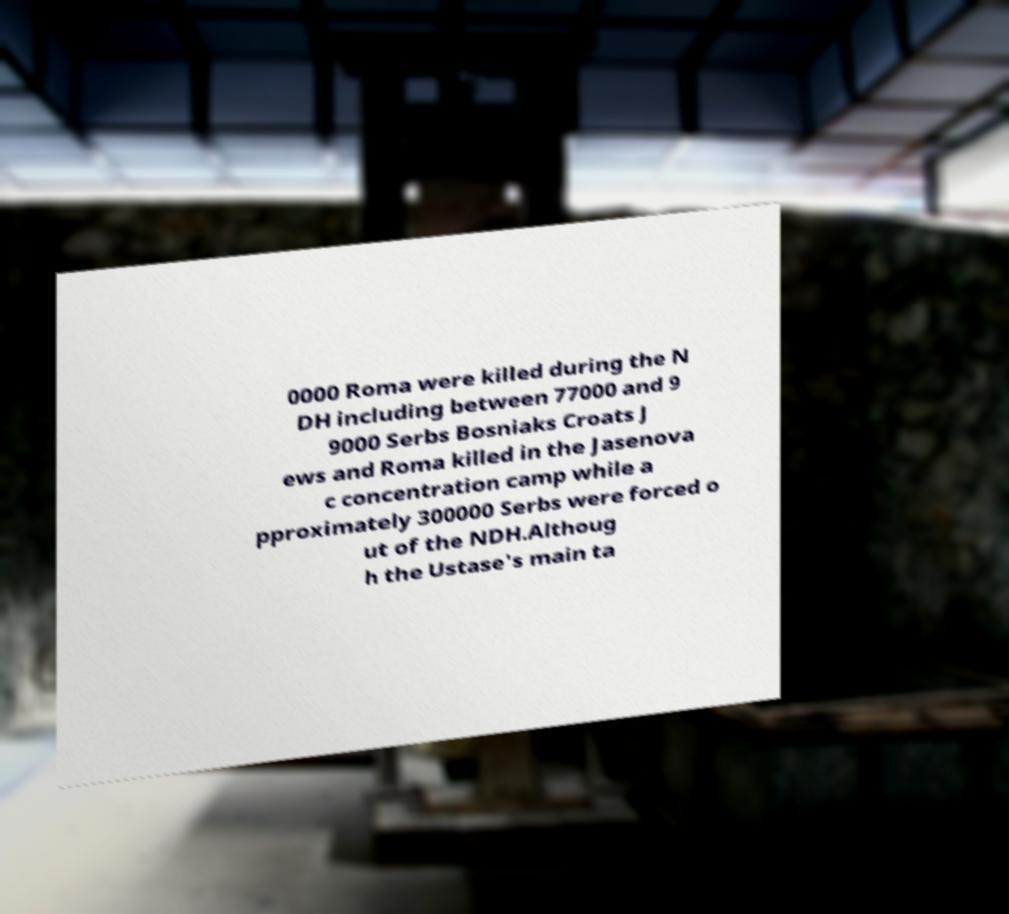There's text embedded in this image that I need extracted. Can you transcribe it verbatim? 0000 Roma were killed during the N DH including between 77000 and 9 9000 Serbs Bosniaks Croats J ews and Roma killed in the Jasenova c concentration camp while a pproximately 300000 Serbs were forced o ut of the NDH.Althoug h the Ustase's main ta 